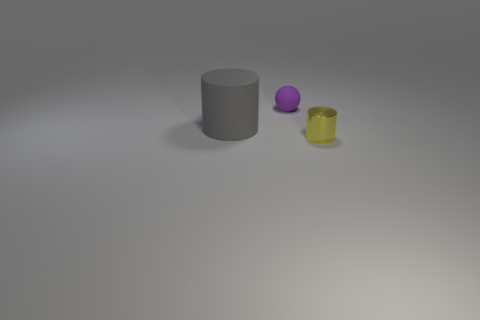Is there anything else that is made of the same material as the tiny yellow cylinder?
Provide a short and direct response. No. Does the cylinder that is in front of the matte cylinder have the same size as the gray rubber object?
Offer a terse response. No. How many other things are there of the same shape as the tiny yellow thing?
Provide a short and direct response. 1. There is a yellow object; how many gray matte cylinders are in front of it?
Provide a succinct answer. 0. How many other things are there of the same size as the metal cylinder?
Your answer should be compact. 1. Are the object that is in front of the large cylinder and the tiny object behind the shiny object made of the same material?
Offer a terse response. No. There is a object that is the same size as the yellow metallic cylinder; what is its color?
Keep it short and to the point. Purple. There is a matte thing that is in front of the thing that is behind the cylinder that is to the left of the small metal object; how big is it?
Keep it short and to the point. Large. The object that is in front of the purple thing and on the right side of the large gray thing is what color?
Your response must be concise. Yellow. What size is the thing on the left side of the tiny rubber thing?
Give a very brief answer. Large. 